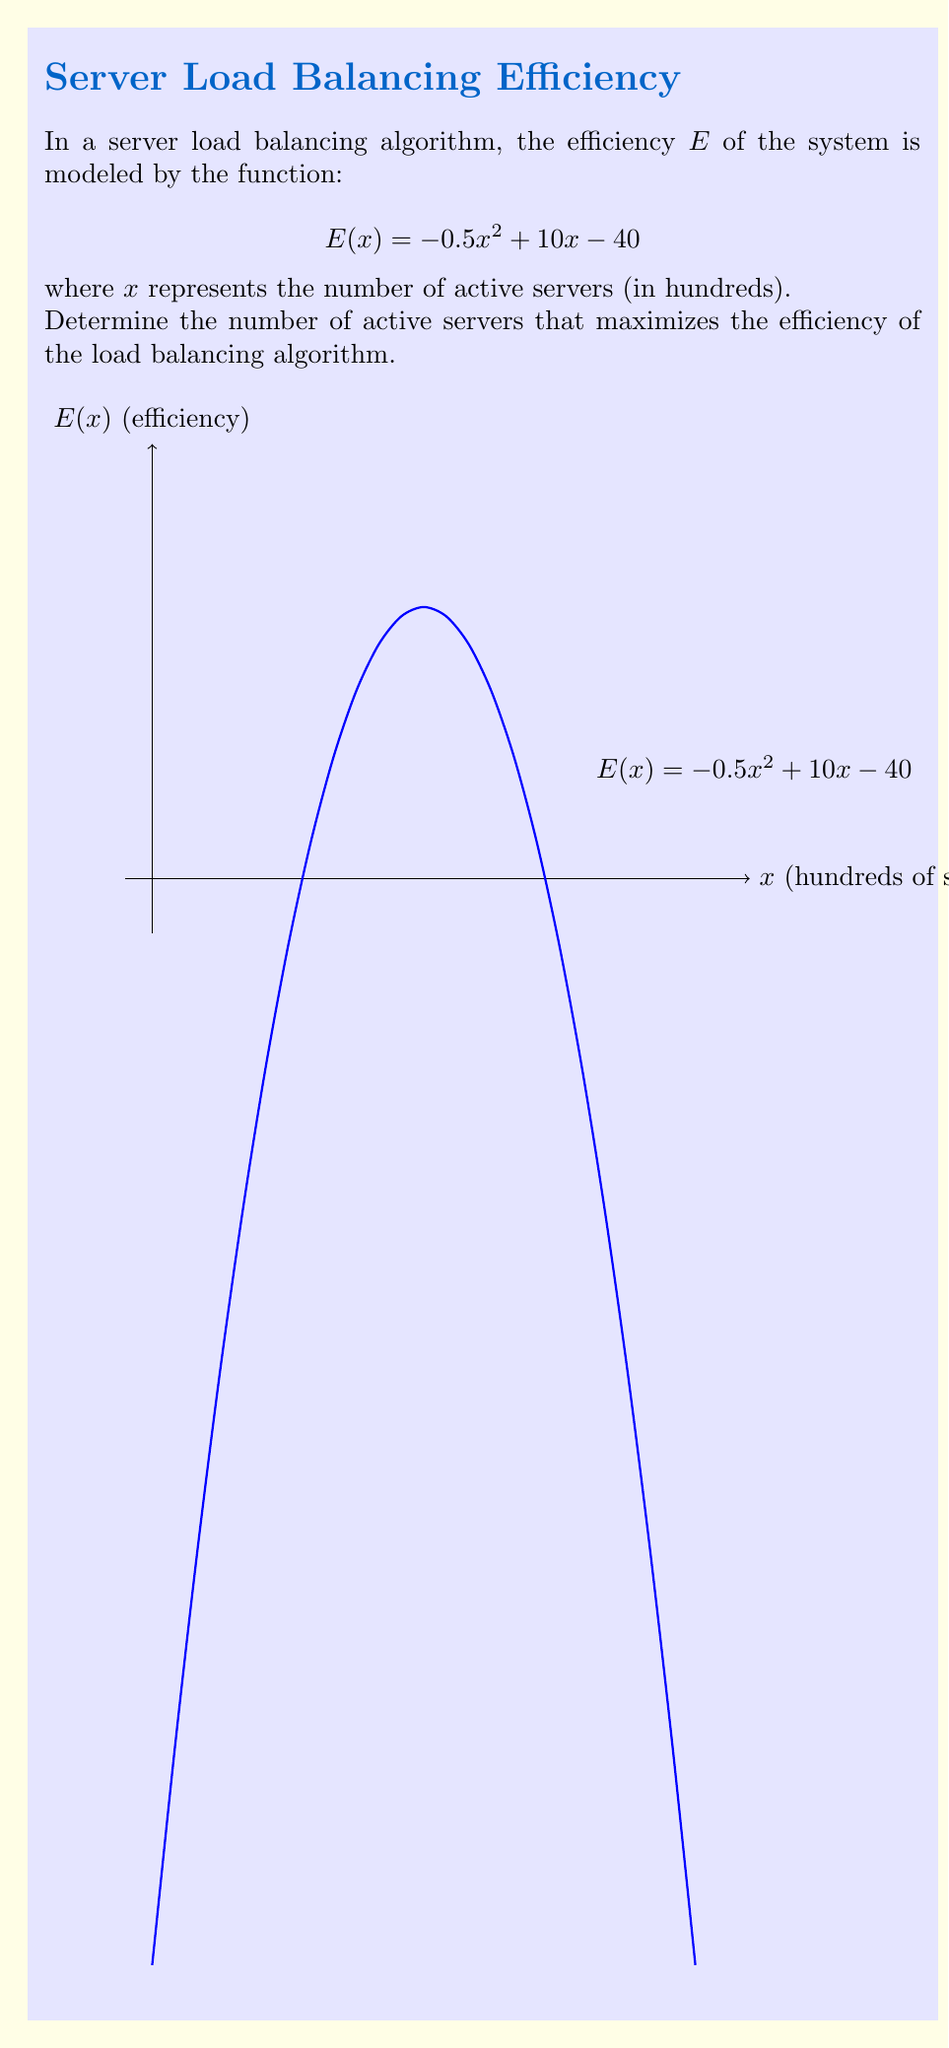Show me your answer to this math problem. To find the maximum efficiency point, we need to find the value of $x$ where the derivative of $E(x)$ equals zero:

1) First, let's find the derivative of $E(x)$:
   $$E'(x) = -x + 10$$

2) Set $E'(x) = 0$ and solve for $x$:
   $$-x + 10 = 0$$
   $$-x = -10$$
   $$x = 10$$

3) To confirm this is a maximum (not a minimum), we can check the second derivative:
   $$E''(x) = -1$$
   Since $E''(x)$ is negative, we confirm that $x = 10$ gives a maximum.

4) Interpret the result:
   $x = 10$ means 10 hundreds of servers, or 1000 servers.

5) Calculate the maximum efficiency:
   $$E(10) = -0.5(10)^2 + 10(10) - 40 = -50 + 100 - 40 = 10$$

Therefore, the efficiency is maximized when there are 1000 active servers, resulting in an efficiency value of 10.
Answer: 1000 servers 